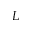Convert formula to latex. <formula><loc_0><loc_0><loc_500><loc_500>L</formula> 